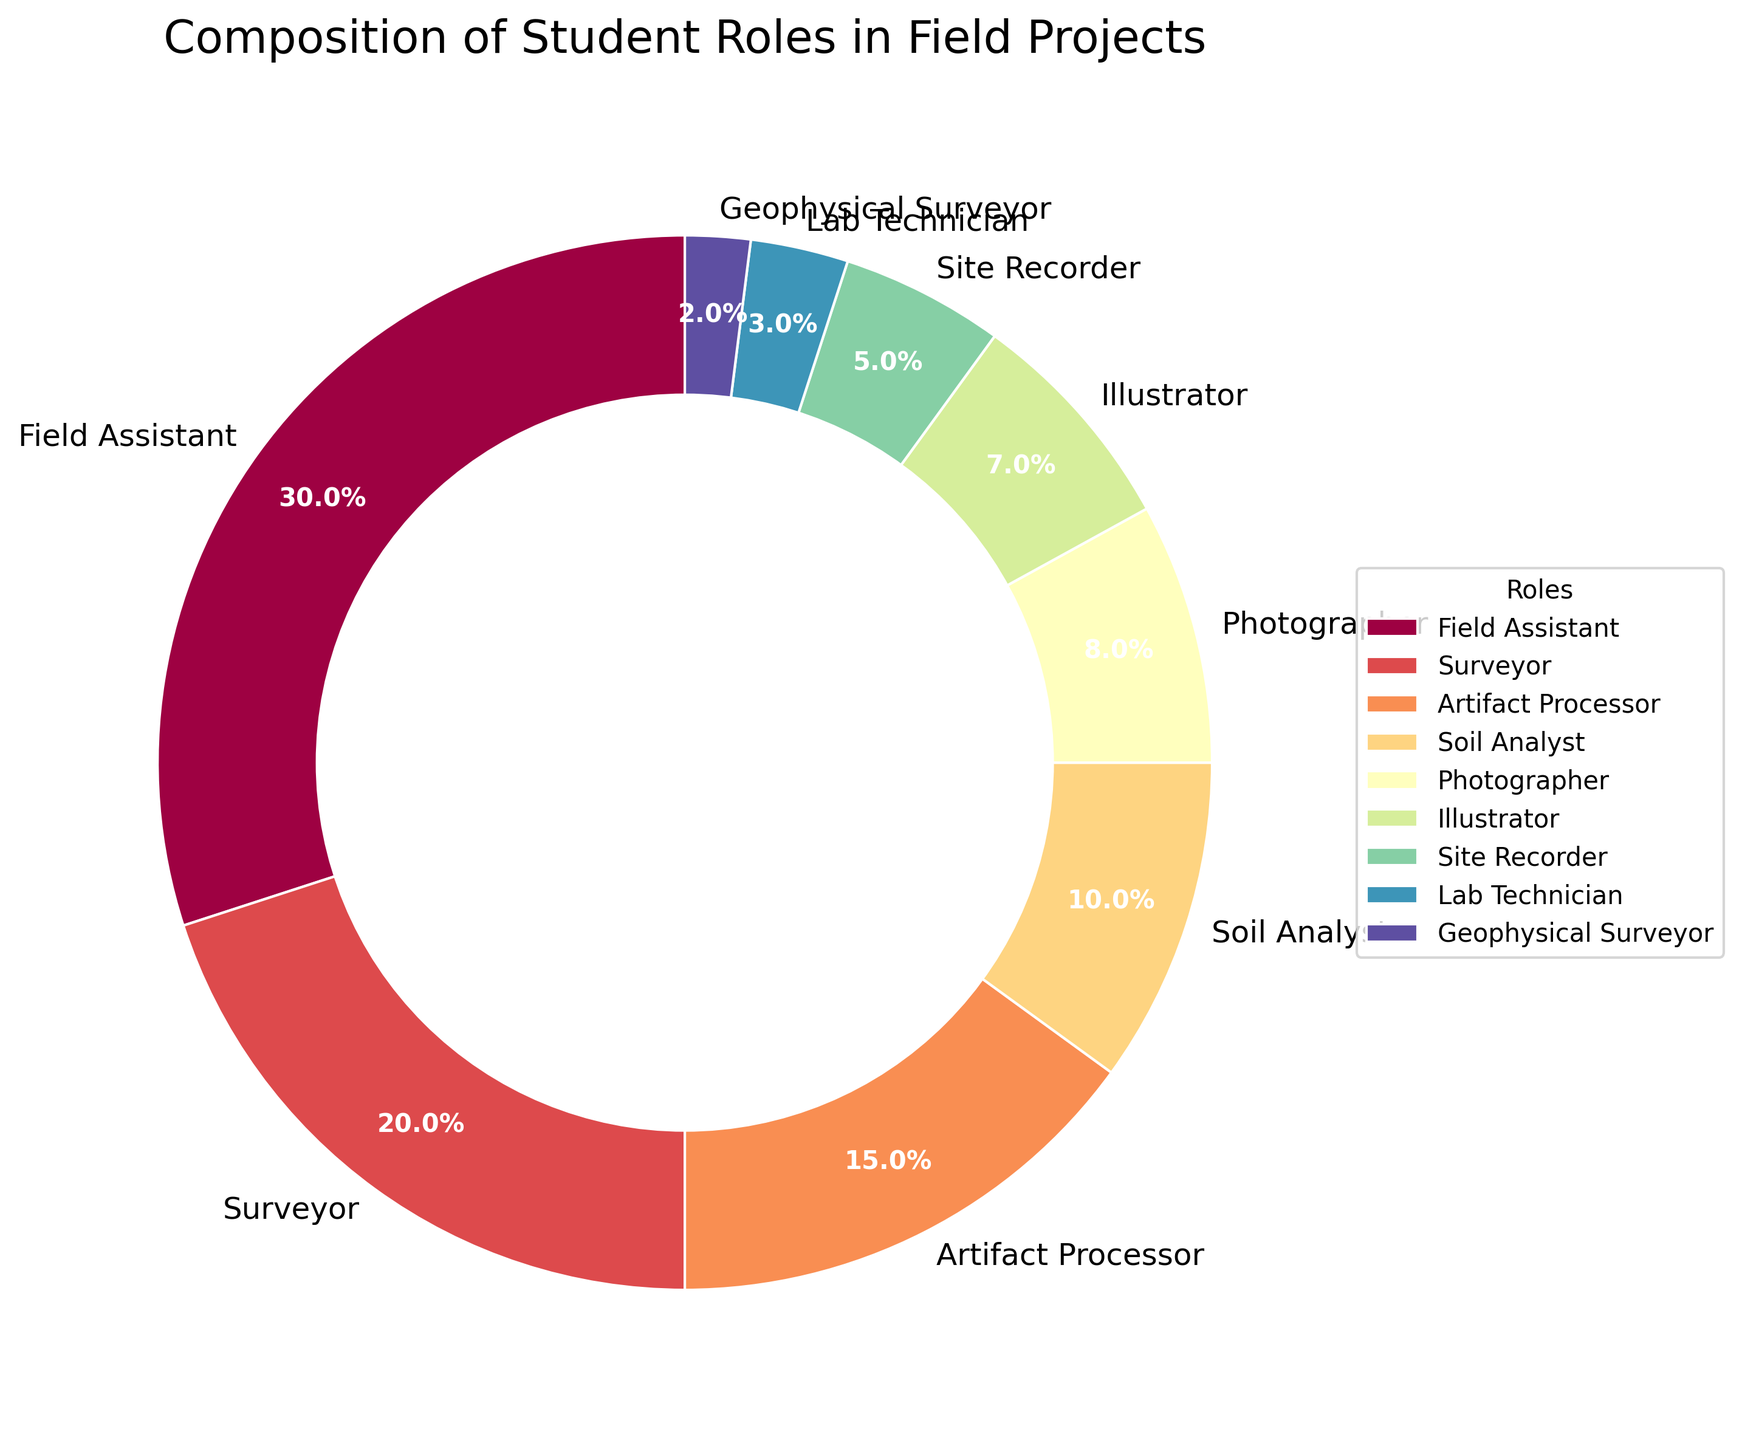What is the combined percentage of Field Assistants and Surveyors? Combine the percentages: Field Assistant (30%) and Surveyor (20%). The combined percentage is 30% + 20% = 50%.
Answer: 50% Which role has the smallest representation in the field projects? Identify the role with the smallest percentage. Geophysical Surveyor has the smallest percentage at 2%.
Answer: Geophysical Surveyor How much greater is the percentage of Field Assistants compared to Site Recorders? Subtract the percentage of Site Recorders (5%) from the percentage of Field Assistants (30%). 30% - 5% = 25%.
Answer: 25% What is the percentage difference between Artifact Processors and Photographers? Subtract the percentage of Photographers (8%) from Artifact Processors (15%). 15% - 8% = 7%.
Answer: 7% How many roles have a percentage less than 10%? Identify roles with percentages less than 10%: Soil Analyst (10%), Photographer (8%), Illustrator (7%), Site Recorder (5%), Lab Technician (3%), Geophysical Surveyor (2%). There are 5 roles with less than 10% representation.
Answer: 6 Which role occupies the most significant portion of the pie chart, and what color is it? Identify the role with the highest percentage, Field Assistant (30%). The color is determined by the chart's color map.
Answer: Field Assistant, color Is the percentage of Surveyors greater than the combined percentage of Site Recorders and Lab Technicians? Compare Surveyor percentage (20%) with the sum of Site Recorder (5%) and Lab Technician (3%). 5% + 3% = 8%, which is less than 20%.
Answer: Yes What is the average percentage of Illustrator and Lab Technician roles? Calculate the average: (Illustrator 7% + Lab Technician 3%) / 2 = 5%.
Answer: 5% Which roles collectively make up more than half of the student roles in the field projects? Sum the percentages of the largest roles until exceeding 50%: Field Assistant (30%) + Surveyor (20%) = 50%. Include the next role, Artifact Processor (15%), to exceed 50%.
Answer: Field Assistant, Surveyor, and Artifact Processor What proportion of the pie chart is occupied by Soil Analysts and Photographers combined? Sum the percentages: Soil Analyst (10%) + Photographer (8%) = 18%.
Answer: 18% 